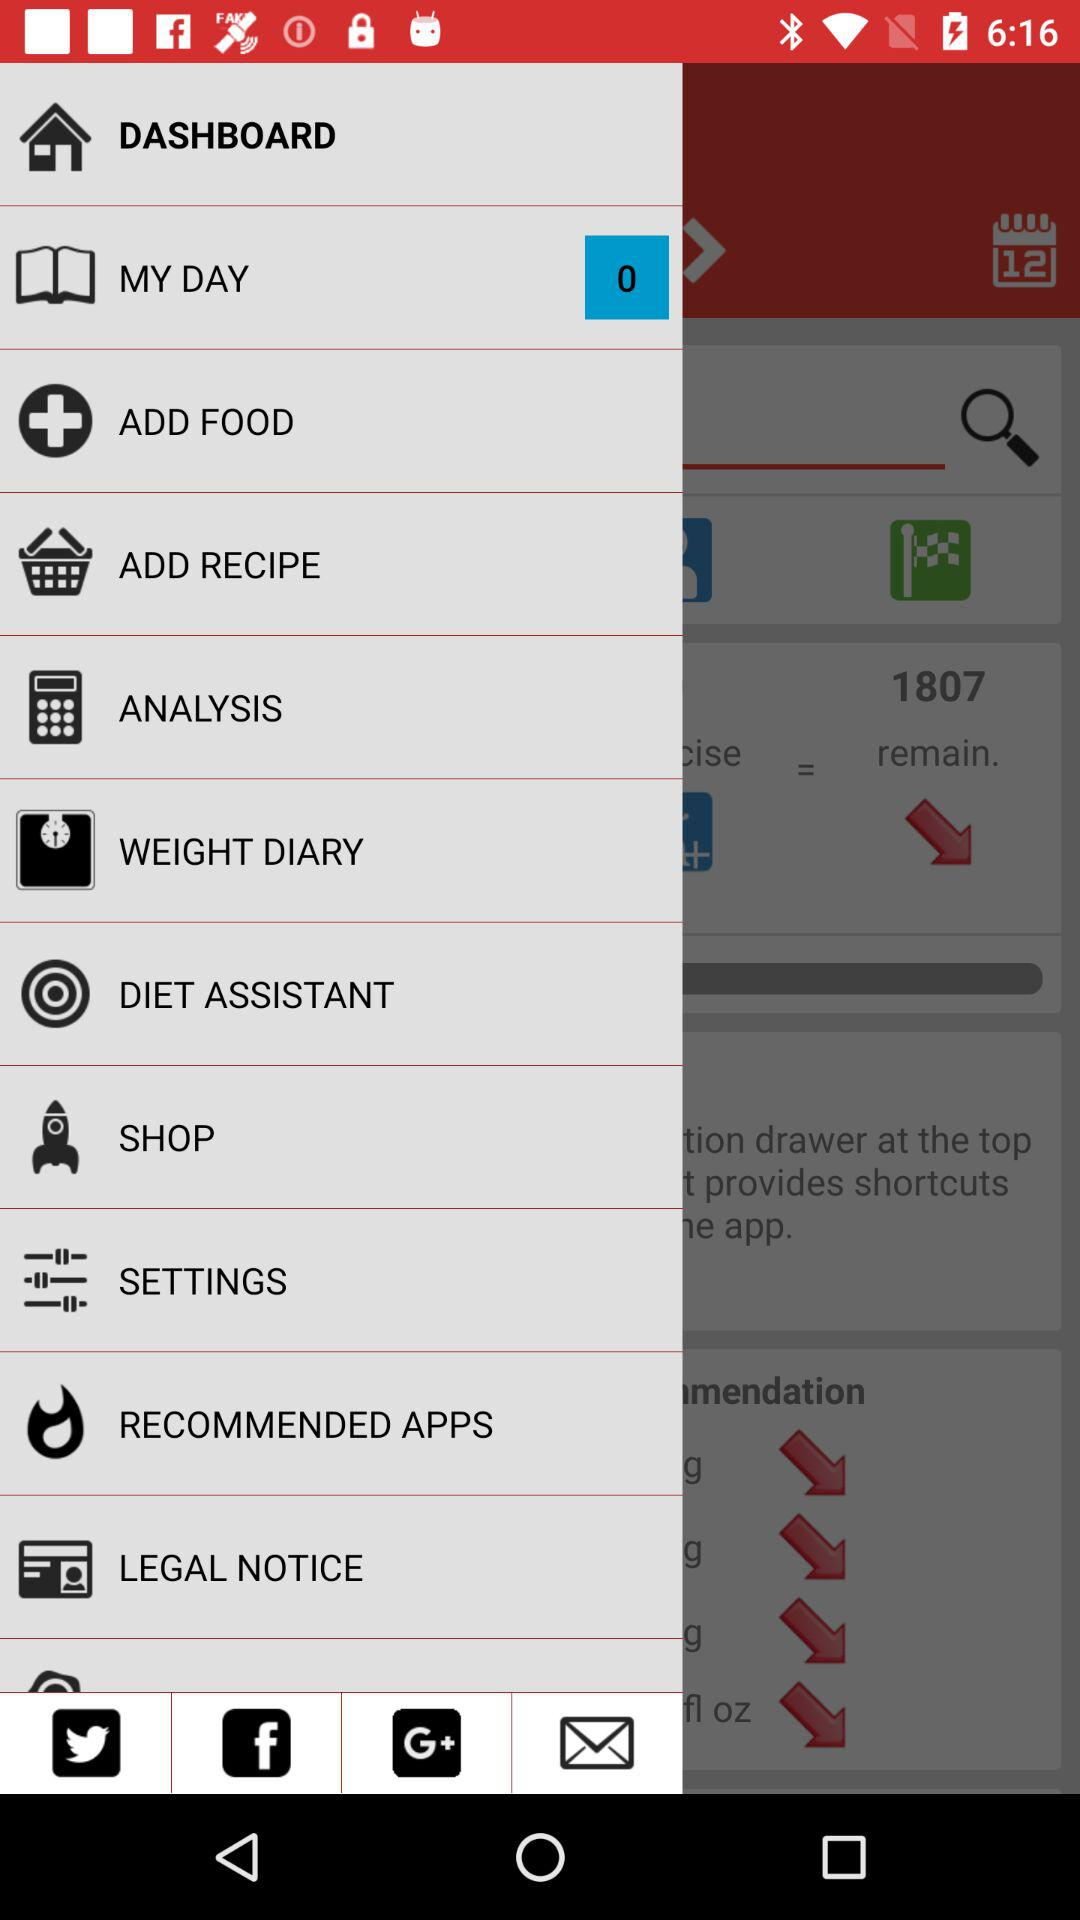What is the count of items in "MY DAY"? The count of items is 0. 